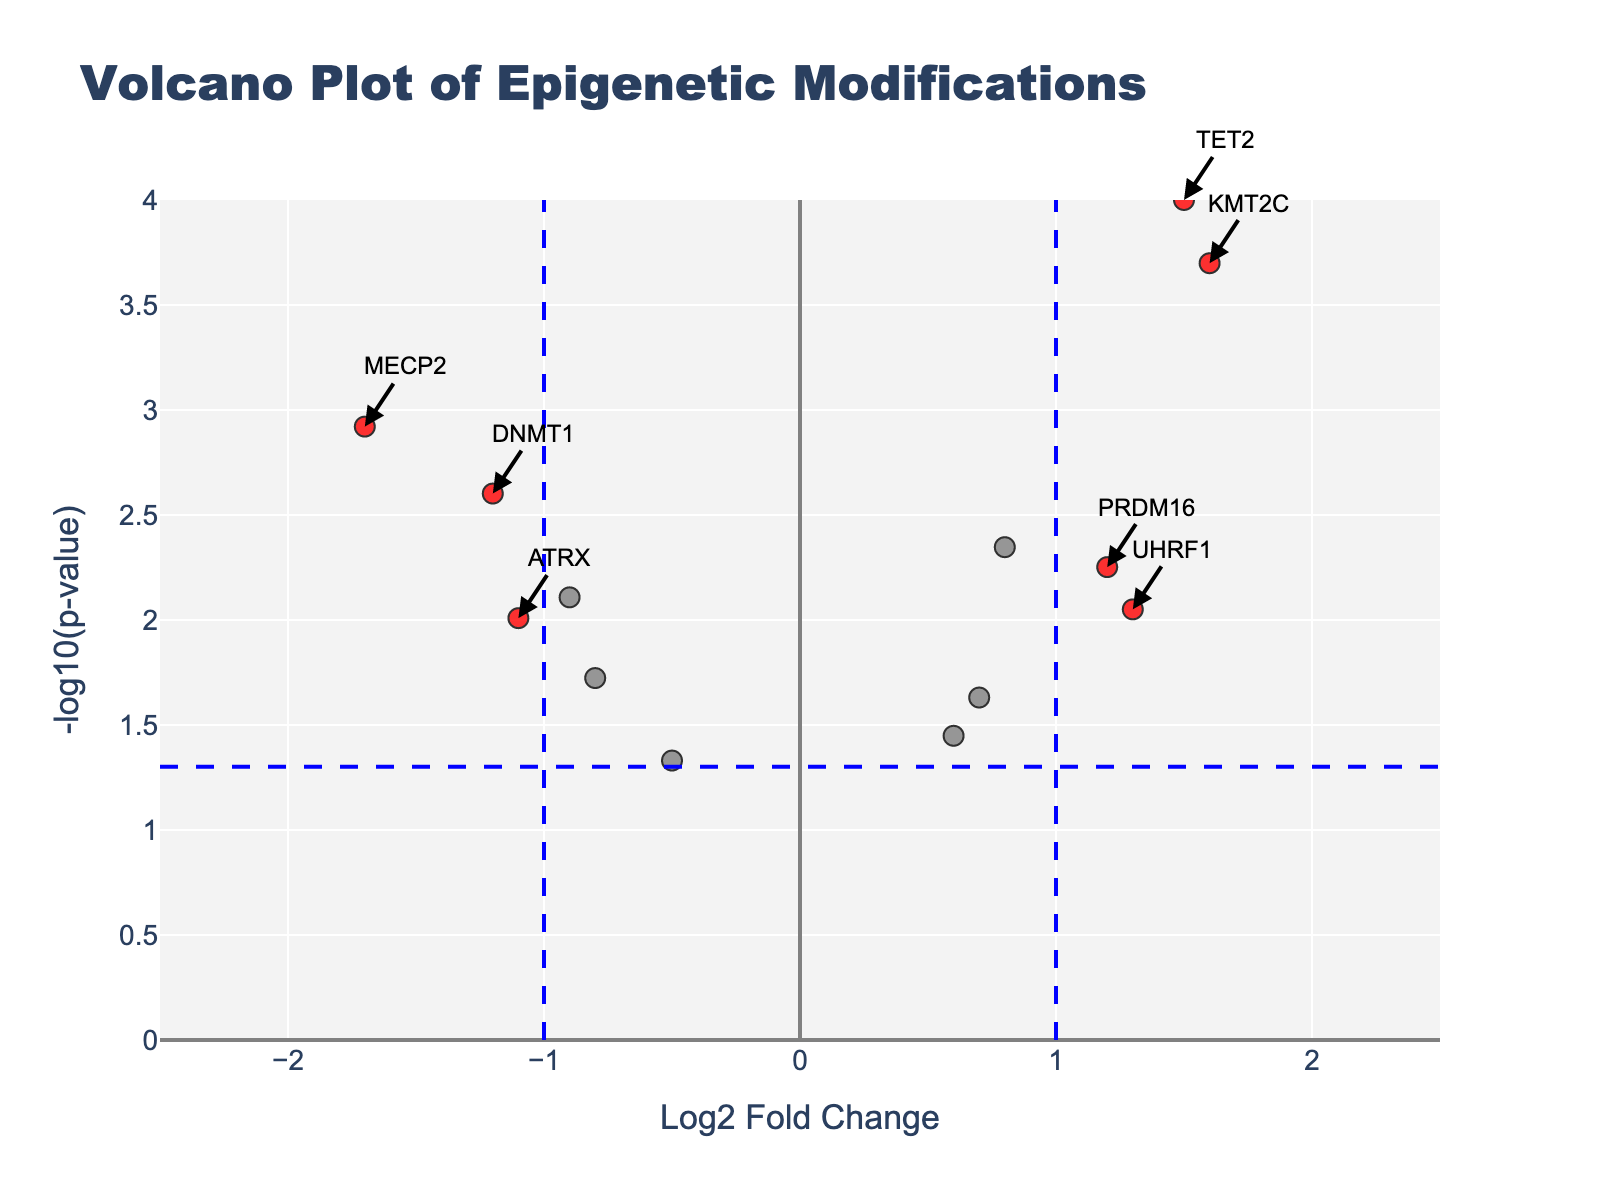What is the title of the Volcano Plot? The title of the plot can be found at the top of the figure. It gives a brief description of what the plot depicts. In this case, the title is "Volcano Plot of Epigenetic Modifications".
Answer: Volcano Plot of Epigenetic Modifications How many genes are marked in red? The genes marked in red represent those that meet both the fold change and p-value significance thresholds. By observing the plot, we can count the number of red points.
Answer: 8 Which gene has the highest -log10(p-value)? The -log10(p-value) is plotted on the y-axis. To find the highest value, look for the point at the topmost position on the y-axis. From the plot, the gene EZH2 has the highest -log10(p-value).
Answer: EZH2 Is the gene DNMT1 upregulated or downregulated? Upregulated genes have positive Log2 Fold Change values, while downregulated genes have negative values. By observing the position of DNMT1 on the x-axis, we see that it has a negative Log2 Fold Change, indicating it is downregulated.
Answer: Downregulated Between the genes TET2 and MECP2, which one has a lower p-value? In a Volcano Plot, a lower p-value corresponds to a higher -log10(p-value) on the y-axis. Compare the vertical positions of TET2 and MECP2 on the plot; TET2 is higher, meaning it has a lower p-value.
Answer: TET2 What are the Log2 Fold Change values that define the thresholds on the x-axis? The vertical dashed blue lines on the x-axis represent the fold change thresholds. These are set at ±1.0, meaning the thresholds are at Log2 Fold Change values of 1.0 and -1.0.
Answer: 1.0 and -1.0 How many genes fall outside the threshold line on the x-axis but are not marked in red? Genes outside the ±1.0 threshold lines on the x-axis are in the upregulated or downregulated categories but not marked in red if they do not meet the p-value threshold. Count these grey points beyond ±1.0 on the x-axis.
Answer: 1 Which gene is closest to the origin in the plot? The origin (0,0) is where the Log2 Fold Change and -log10(p-value) intersect at their minimum values. The gene closest to this point can be identified by finding the point nearest to the intersection. KAT2A is the gene closest to the origin.
Answer: KAT2A 